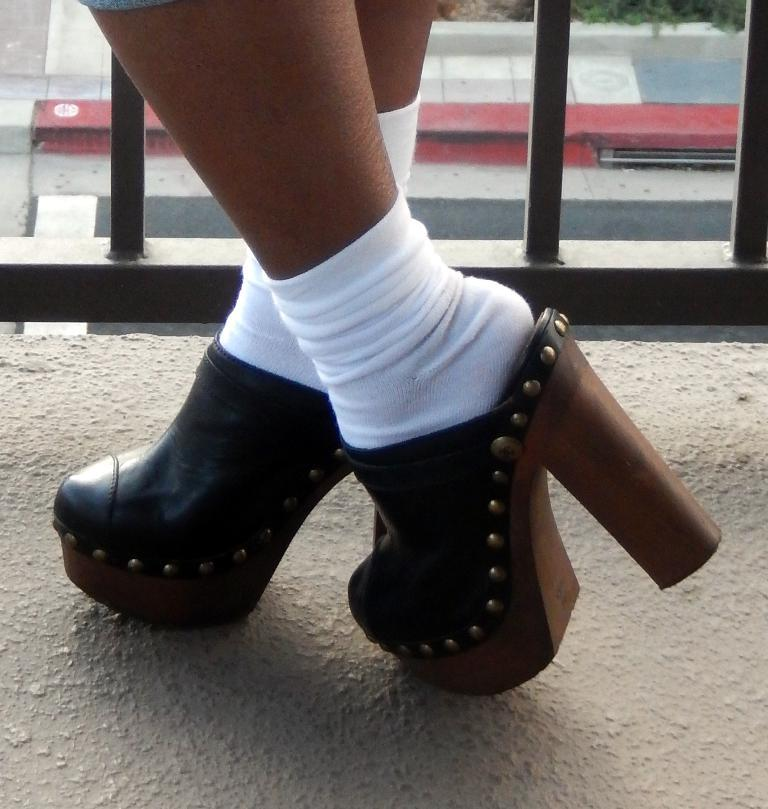Who or what is present in the image? There is a person in the image. What type of footwear is the person wearing? The person is wearing shoes. What objects are located near the person? There are metal rods beside the person. What type of chairs can be seen in the image? There are no chairs present in the image. 